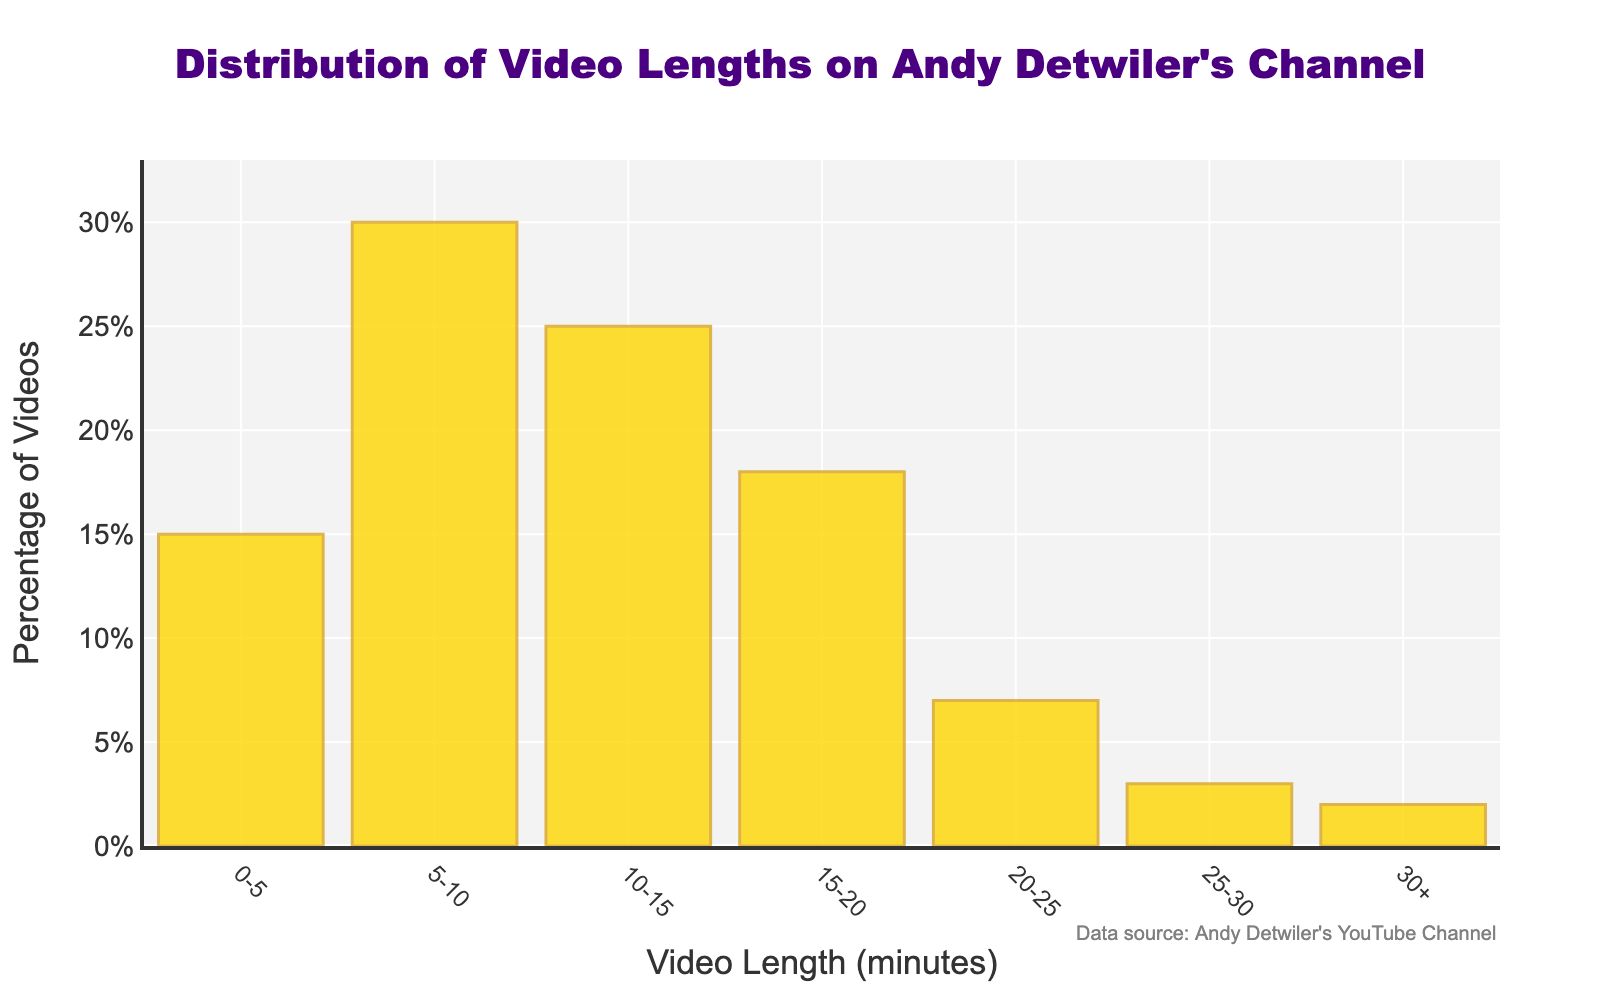What percentage of Andy Detwiler's videos are longer than 20 minutes? To determine this, sum the percentages of videos in the 20-25, 25-30, and 30+ minute categories. 7% (20-25 min) + 3% (25-30 min) + 2% (30+ min) = 12%
Answer: 12% Which video length category has the highest percentage of videos? Look for the highest bar in the chart; the video length category with the highest bar represents the highest percentage. The 5-10 minute category is the tallest, representing 30%
Answer: 5-10 minutes What is the difference in percentage between videos that are 5-10 minutes long and videos that are 10-15 minutes long? Subtract the percentage of the 10-15 minute category from the 5-10 minute category. 30% (5-10 min) - 25% (10-15 min) = 5%
Answer: 5% How many video length categories have a percentage of videos greater than 20%? Identify categories where the percentage is more than 20%. The categories 5-10 minutes (30%) and 10-15 minutes (25%) both exceed 20%
Answer: 2 What is the combined percentage of videos that are less than 10 minutes long? Sum the percentages of the 0-5 minute and 5-10 minute categories. 15% (0-5 min) + 30% (5-10 min) = 45%
Answer: 45% Which video length category has the smallest percentage of videos? Look for the shortest bar in the chart; the category with the smallest bar represents the lowest percentage. The 30+ minute category at 2%
Answer: 30+ minutes Is the percentage of videos that are 10-15 minutes long greater than the percentage of videos that are 15-20 minutes long? Compare the heights of the bars for the 10-15 minute category and the 15-20 minute category. Yes, 25% (10-15 min) is greater than 18% (15-20 min)
Answer: Yes What's the percentage difference between the video length categories 15-20 minutes and 20-25 minutes? Subtract the percentage of the 20-25 minute category from the 15-20 minute category. 18% (15-20 min) - 7% (20-25 min) = 11%
Answer: 11% 